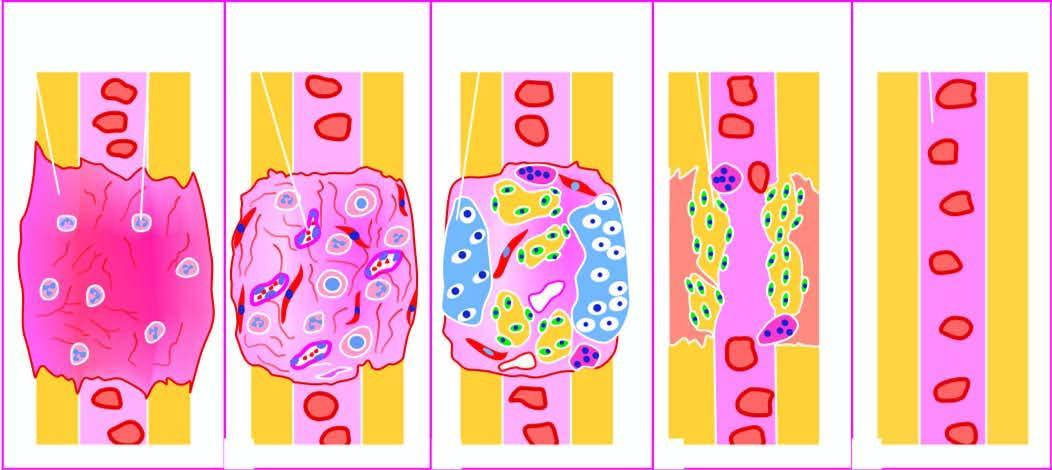s intermediate callus converted into lamellar bone and internal callus developing bone marrow cavity?
Answer the question using a single word or phrase. Yes 